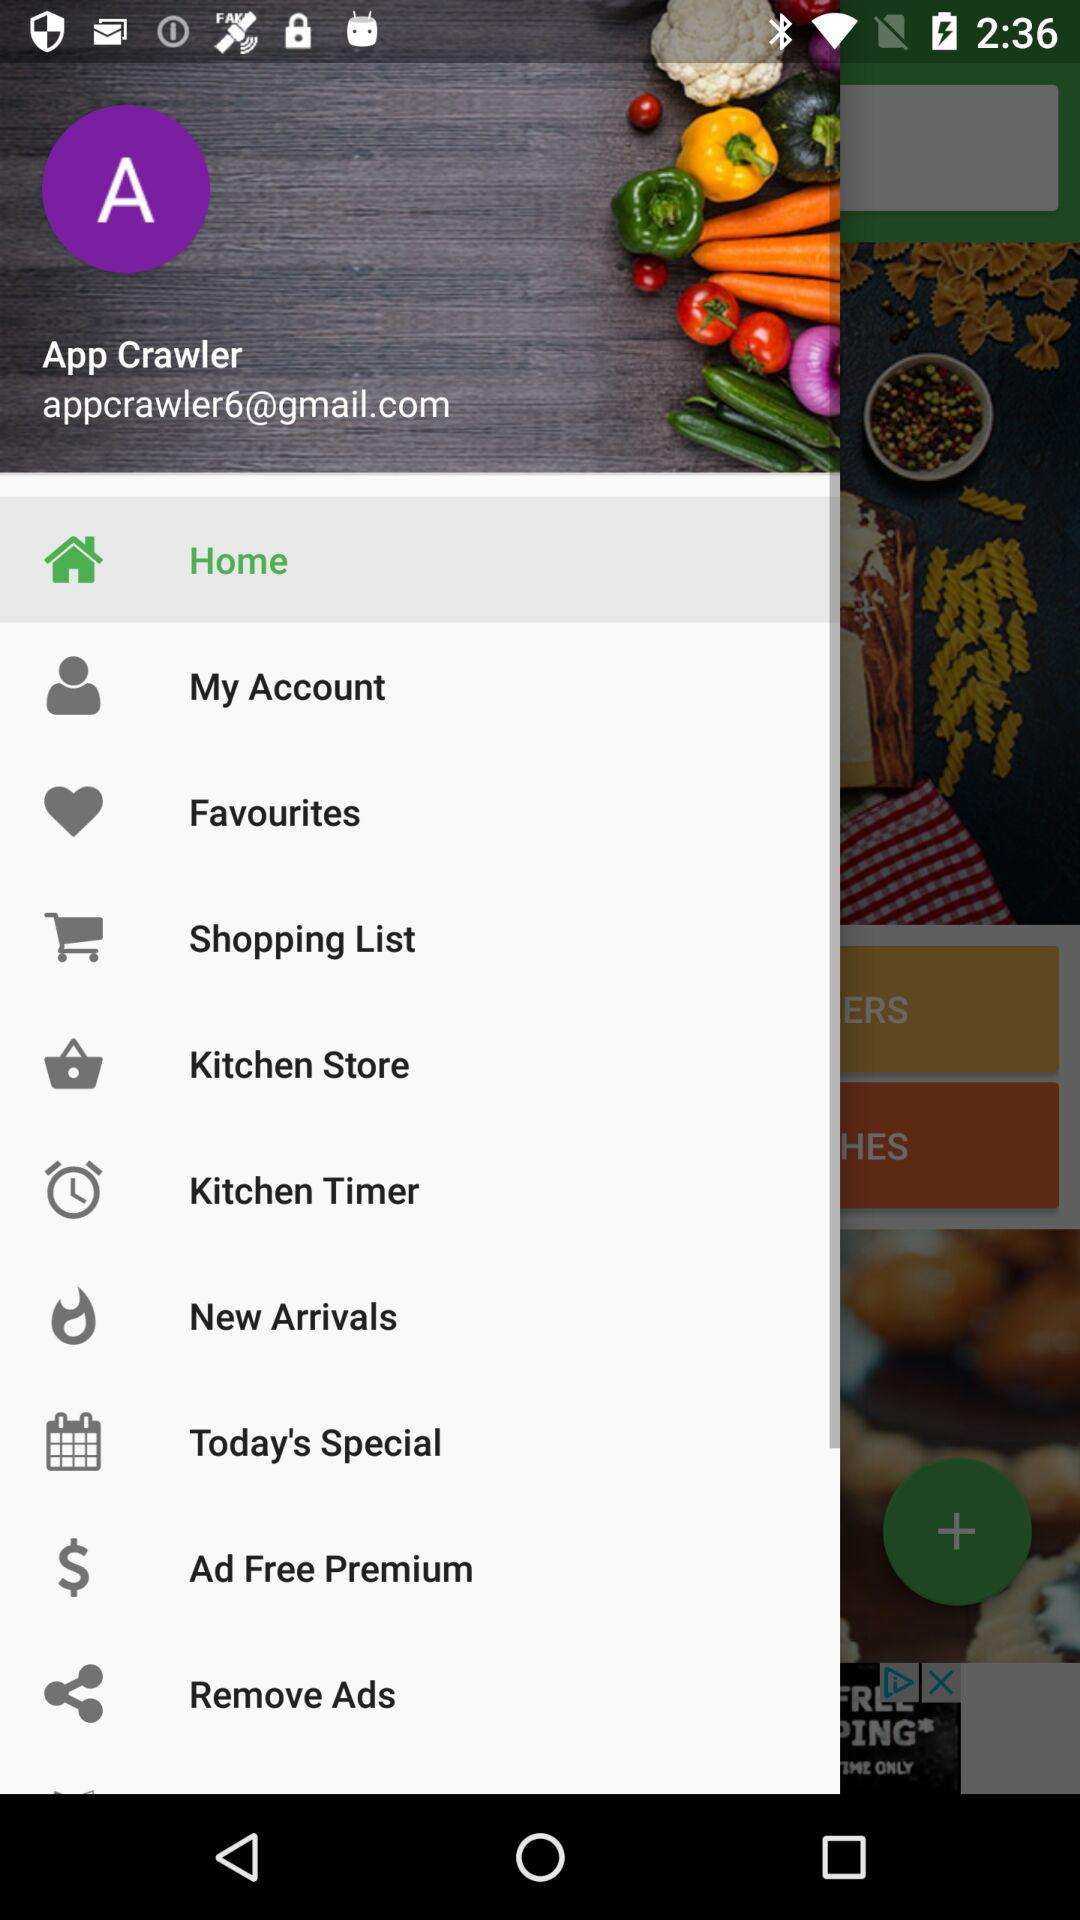What is the user name? The user name is App Crawler. 